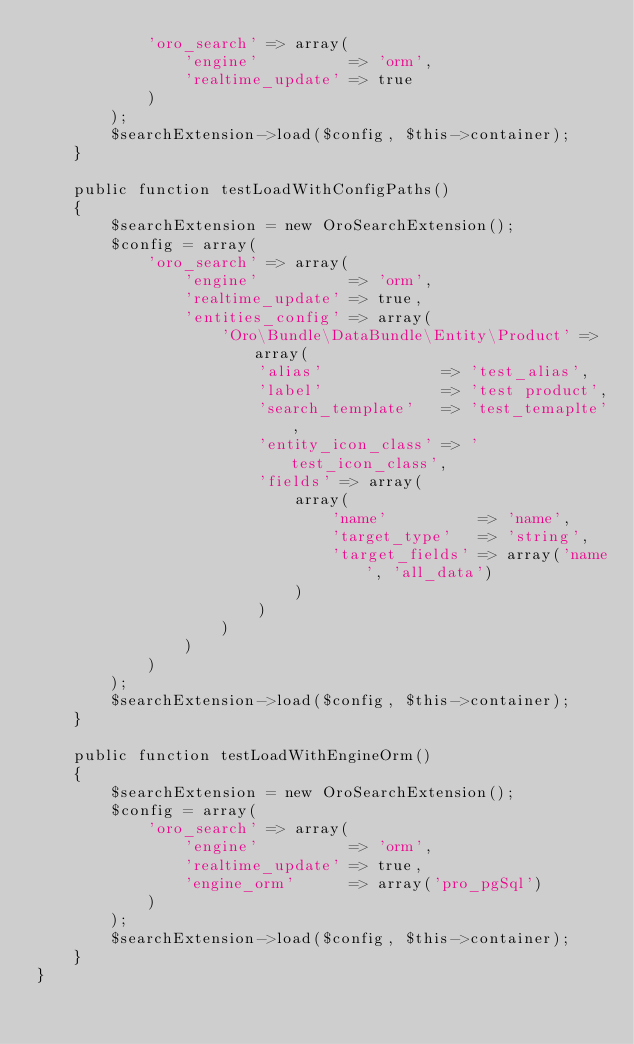Convert code to text. <code><loc_0><loc_0><loc_500><loc_500><_PHP_>            'oro_search' => array(
                'engine'          => 'orm',
                'realtime_update' => true
            )
        );
        $searchExtension->load($config, $this->container);
    }

    public function testLoadWithConfigPaths()
    {
        $searchExtension = new OroSearchExtension();
        $config = array(
            'oro_search' => array(
                'engine'          => 'orm',
                'realtime_update' => true,
                'entities_config' => array(
                    'Oro\Bundle\DataBundle\Entity\Product' => array(
                        'alias'             => 'test_alias',
                        'label'             => 'test product',
                        'search_template'   => 'test_temaplte',
                        'entity_icon_class' => 'test_icon_class',
                        'fields' => array(
                            array(
                                'name'          => 'name',
                                'target_type'   => 'string',
                                'target_fields' => array('name', 'all_data')
                            )
                        )
                    )
                )
            )
        );
        $searchExtension->load($config, $this->container);
    }

    public function testLoadWithEngineOrm()
    {
        $searchExtension = new OroSearchExtension();
        $config = array(
            'oro_search' => array(
                'engine'          => 'orm',
                'realtime_update' => true,
                'engine_orm'      => array('pro_pgSql')
            )
        );
        $searchExtension->load($config, $this->container);
    }
}
</code> 